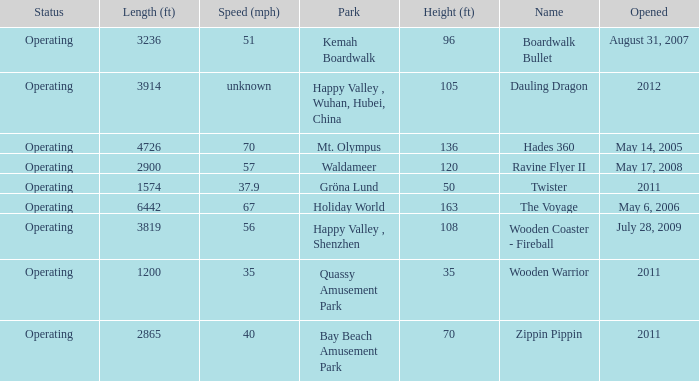What is the length of the coaster with the unknown speed 3914.0. 